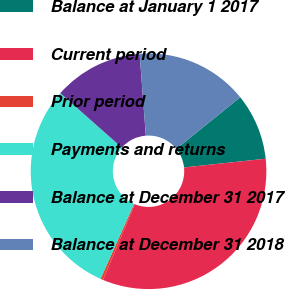Convert chart. <chart><loc_0><loc_0><loc_500><loc_500><pie_chart><fcel>Balance at January 1 2017<fcel>Current period<fcel>Prior period<fcel>Payments and returns<fcel>Balance at December 31 2017<fcel>Balance at December 31 2018<nl><fcel>9.11%<fcel>33.01%<fcel>0.36%<fcel>29.86%<fcel>12.26%<fcel>15.4%<nl></chart> 